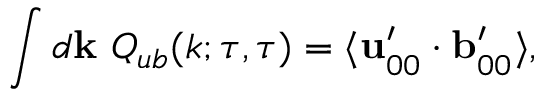<formula> <loc_0><loc_0><loc_500><loc_500>\int d { k } \ Q _ { u b } ( k ; \tau , \tau ) = \langle { { u } _ { 0 0 } ^ { \prime } \cdot { b } _ { 0 0 } ^ { \prime } } \rangle ,</formula> 